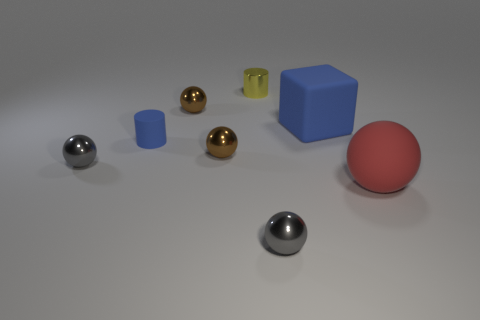Are there any blocks of the same size as the matte ball?
Make the answer very short. Yes. There is another cylinder that is the same size as the yellow metallic cylinder; what material is it?
Give a very brief answer. Rubber. Is the size of the red matte thing the same as the blue object behind the small blue cylinder?
Give a very brief answer. Yes. What material is the big thing that is behind the blue matte cylinder?
Your response must be concise. Rubber. Are there the same number of large red things that are behind the blue cylinder and small yellow rubber cubes?
Ensure brevity in your answer.  Yes. Do the blue matte cylinder and the red matte ball have the same size?
Provide a succinct answer. No. There is a brown metal sphere that is behind the large blue object that is in front of the small yellow object; is there a large blue rubber block to the left of it?
Provide a succinct answer. No. There is another object that is the same shape as the small matte object; what is it made of?
Provide a succinct answer. Metal. How many metallic spheres are in front of the gray metal ball on the right side of the tiny blue rubber cylinder?
Make the answer very short. 0. What is the size of the gray metal object in front of the big thing in front of the gray thing that is to the left of the small yellow metallic thing?
Provide a succinct answer. Small. 